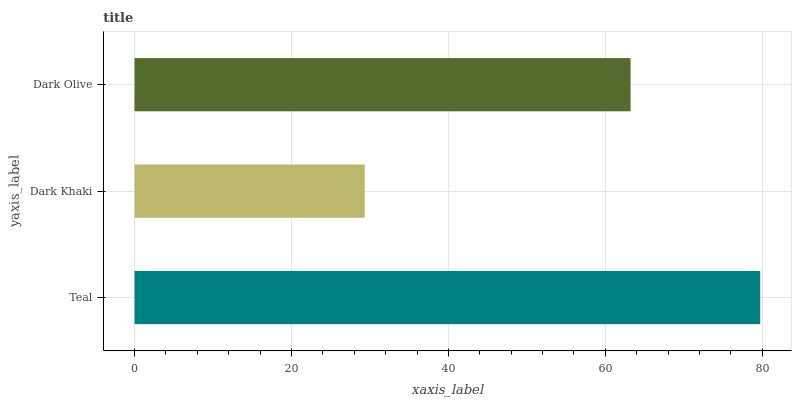Is Dark Khaki the minimum?
Answer yes or no. Yes. Is Teal the maximum?
Answer yes or no. Yes. Is Dark Olive the minimum?
Answer yes or no. No. Is Dark Olive the maximum?
Answer yes or no. No. Is Dark Olive greater than Dark Khaki?
Answer yes or no. Yes. Is Dark Khaki less than Dark Olive?
Answer yes or no. Yes. Is Dark Khaki greater than Dark Olive?
Answer yes or no. No. Is Dark Olive less than Dark Khaki?
Answer yes or no. No. Is Dark Olive the high median?
Answer yes or no. Yes. Is Dark Olive the low median?
Answer yes or no. Yes. Is Dark Khaki the high median?
Answer yes or no. No. Is Dark Khaki the low median?
Answer yes or no. No. 